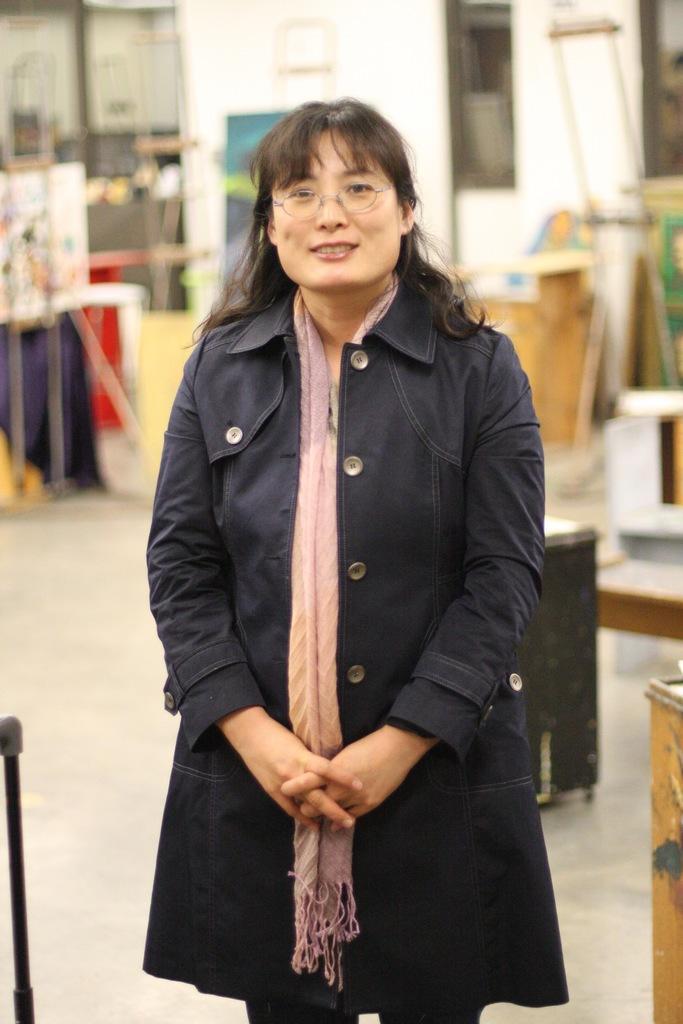Please provide a concise description of this image. In the center of the image we can see a lady standing. She is wearing a coat. In the background there are tables and a wall. 